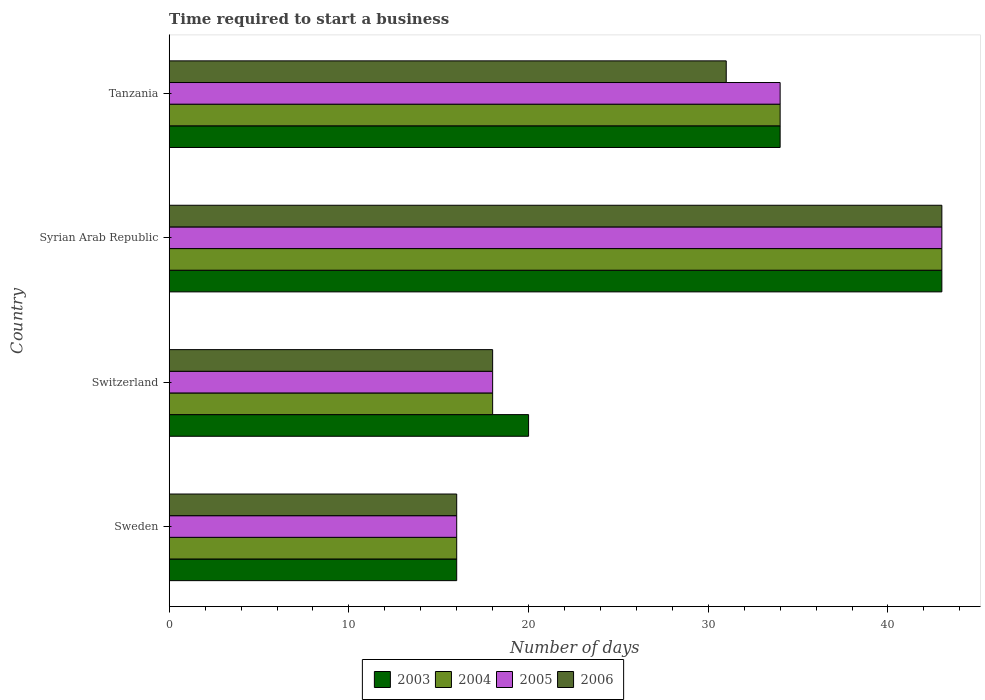Are the number of bars on each tick of the Y-axis equal?
Your response must be concise. Yes. What is the label of the 4th group of bars from the top?
Offer a very short reply. Sweden. In how many cases, is the number of bars for a given country not equal to the number of legend labels?
Give a very brief answer. 0. Across all countries, what is the minimum number of days required to start a business in 2005?
Give a very brief answer. 16. In which country was the number of days required to start a business in 2004 maximum?
Offer a very short reply. Syrian Arab Republic. In which country was the number of days required to start a business in 2004 minimum?
Your answer should be compact. Sweden. What is the total number of days required to start a business in 2006 in the graph?
Your answer should be compact. 108. What is the difference between the number of days required to start a business in 2003 in Syrian Arab Republic and that in Tanzania?
Your answer should be very brief. 9. What is the difference between the number of days required to start a business in 2005 in Syrian Arab Republic and the number of days required to start a business in 2003 in Sweden?
Your answer should be very brief. 27. What is the average number of days required to start a business in 2005 per country?
Offer a very short reply. 27.75. In how many countries, is the number of days required to start a business in 2006 greater than 22 days?
Make the answer very short. 2. What is the ratio of the number of days required to start a business in 2004 in Switzerland to that in Tanzania?
Ensure brevity in your answer.  0.53. Is the difference between the number of days required to start a business in 2006 in Sweden and Tanzania greater than the difference between the number of days required to start a business in 2005 in Sweden and Tanzania?
Keep it short and to the point. Yes. Is the sum of the number of days required to start a business in 2005 in Switzerland and Syrian Arab Republic greater than the maximum number of days required to start a business in 2004 across all countries?
Your answer should be very brief. Yes. What does the 3rd bar from the top in Syrian Arab Republic represents?
Provide a succinct answer. 2004. How many bars are there?
Offer a terse response. 16. How many countries are there in the graph?
Provide a succinct answer. 4. Does the graph contain any zero values?
Give a very brief answer. No. Does the graph contain grids?
Provide a short and direct response. No. How many legend labels are there?
Provide a succinct answer. 4. What is the title of the graph?
Your answer should be compact. Time required to start a business. Does "1974" appear as one of the legend labels in the graph?
Offer a terse response. No. What is the label or title of the X-axis?
Your response must be concise. Number of days. What is the Number of days in 2005 in Sweden?
Your answer should be very brief. 16. What is the Number of days of 2003 in Switzerland?
Keep it short and to the point. 20. What is the Number of days in 2006 in Switzerland?
Ensure brevity in your answer.  18. What is the Number of days in 2004 in Syrian Arab Republic?
Give a very brief answer. 43. What is the Number of days in 2006 in Syrian Arab Republic?
Give a very brief answer. 43. Across all countries, what is the maximum Number of days in 2004?
Your answer should be compact. 43. Across all countries, what is the maximum Number of days of 2005?
Offer a terse response. 43. Across all countries, what is the minimum Number of days of 2004?
Your response must be concise. 16. Across all countries, what is the minimum Number of days in 2005?
Ensure brevity in your answer.  16. What is the total Number of days of 2003 in the graph?
Offer a very short reply. 113. What is the total Number of days in 2004 in the graph?
Provide a succinct answer. 111. What is the total Number of days of 2005 in the graph?
Give a very brief answer. 111. What is the total Number of days in 2006 in the graph?
Offer a very short reply. 108. What is the difference between the Number of days of 2004 in Sweden and that in Switzerland?
Offer a very short reply. -2. What is the difference between the Number of days in 2005 in Sweden and that in Switzerland?
Provide a short and direct response. -2. What is the difference between the Number of days of 2006 in Sweden and that in Switzerland?
Your answer should be very brief. -2. What is the difference between the Number of days in 2005 in Sweden and that in Syrian Arab Republic?
Offer a very short reply. -27. What is the difference between the Number of days in 2006 in Sweden and that in Syrian Arab Republic?
Your response must be concise. -27. What is the difference between the Number of days of 2003 in Sweden and that in Tanzania?
Provide a short and direct response. -18. What is the difference between the Number of days in 2003 in Switzerland and that in Syrian Arab Republic?
Provide a short and direct response. -23. What is the difference between the Number of days of 2004 in Switzerland and that in Syrian Arab Republic?
Offer a terse response. -25. What is the difference between the Number of days in 2005 in Switzerland and that in Syrian Arab Republic?
Offer a very short reply. -25. What is the difference between the Number of days in 2006 in Switzerland and that in Syrian Arab Republic?
Your answer should be compact. -25. What is the difference between the Number of days of 2004 in Switzerland and that in Tanzania?
Provide a succinct answer. -16. What is the difference between the Number of days of 2005 in Switzerland and that in Tanzania?
Give a very brief answer. -16. What is the difference between the Number of days in 2003 in Syrian Arab Republic and that in Tanzania?
Make the answer very short. 9. What is the difference between the Number of days of 2004 in Syrian Arab Republic and that in Tanzania?
Provide a succinct answer. 9. What is the difference between the Number of days of 2006 in Syrian Arab Republic and that in Tanzania?
Your response must be concise. 12. What is the difference between the Number of days in 2003 in Sweden and the Number of days in 2006 in Switzerland?
Offer a terse response. -2. What is the difference between the Number of days in 2004 in Sweden and the Number of days in 2005 in Switzerland?
Offer a terse response. -2. What is the difference between the Number of days of 2004 in Sweden and the Number of days of 2006 in Switzerland?
Make the answer very short. -2. What is the difference between the Number of days of 2003 in Sweden and the Number of days of 2004 in Syrian Arab Republic?
Provide a succinct answer. -27. What is the difference between the Number of days of 2004 in Sweden and the Number of days of 2006 in Syrian Arab Republic?
Keep it short and to the point. -27. What is the difference between the Number of days in 2003 in Sweden and the Number of days in 2005 in Tanzania?
Keep it short and to the point. -18. What is the difference between the Number of days in 2005 in Sweden and the Number of days in 2006 in Tanzania?
Offer a very short reply. -15. What is the difference between the Number of days of 2003 in Switzerland and the Number of days of 2004 in Syrian Arab Republic?
Your response must be concise. -23. What is the difference between the Number of days of 2004 in Switzerland and the Number of days of 2005 in Syrian Arab Republic?
Provide a succinct answer. -25. What is the difference between the Number of days of 2005 in Switzerland and the Number of days of 2006 in Syrian Arab Republic?
Your answer should be very brief. -25. What is the difference between the Number of days of 2003 in Switzerland and the Number of days of 2005 in Tanzania?
Offer a very short reply. -14. What is the difference between the Number of days in 2003 in Switzerland and the Number of days in 2006 in Tanzania?
Make the answer very short. -11. What is the difference between the Number of days of 2004 in Switzerland and the Number of days of 2006 in Tanzania?
Ensure brevity in your answer.  -13. What is the difference between the Number of days in 2003 in Syrian Arab Republic and the Number of days in 2004 in Tanzania?
Offer a very short reply. 9. What is the difference between the Number of days in 2003 in Syrian Arab Republic and the Number of days in 2005 in Tanzania?
Your response must be concise. 9. What is the difference between the Number of days in 2003 in Syrian Arab Republic and the Number of days in 2006 in Tanzania?
Make the answer very short. 12. What is the difference between the Number of days of 2004 in Syrian Arab Republic and the Number of days of 2006 in Tanzania?
Ensure brevity in your answer.  12. What is the difference between the Number of days of 2005 in Syrian Arab Republic and the Number of days of 2006 in Tanzania?
Make the answer very short. 12. What is the average Number of days of 2003 per country?
Provide a succinct answer. 28.25. What is the average Number of days of 2004 per country?
Provide a succinct answer. 27.75. What is the average Number of days of 2005 per country?
Offer a very short reply. 27.75. What is the difference between the Number of days of 2003 and Number of days of 2004 in Sweden?
Give a very brief answer. 0. What is the difference between the Number of days in 2003 and Number of days in 2005 in Sweden?
Make the answer very short. 0. What is the difference between the Number of days in 2004 and Number of days in 2005 in Sweden?
Your answer should be compact. 0. What is the difference between the Number of days of 2003 and Number of days of 2004 in Switzerland?
Offer a very short reply. 2. What is the difference between the Number of days of 2004 and Number of days of 2005 in Switzerland?
Offer a terse response. 0. What is the difference between the Number of days in 2005 and Number of days in 2006 in Switzerland?
Your answer should be very brief. 0. What is the difference between the Number of days in 2003 and Number of days in 2005 in Syrian Arab Republic?
Your response must be concise. 0. What is the difference between the Number of days of 2005 and Number of days of 2006 in Syrian Arab Republic?
Offer a terse response. 0. What is the difference between the Number of days of 2003 and Number of days of 2004 in Tanzania?
Your response must be concise. 0. What is the difference between the Number of days in 2003 and Number of days in 2006 in Tanzania?
Give a very brief answer. 3. What is the difference between the Number of days of 2004 and Number of days of 2006 in Tanzania?
Give a very brief answer. 3. What is the ratio of the Number of days of 2003 in Sweden to that in Switzerland?
Give a very brief answer. 0.8. What is the ratio of the Number of days of 2004 in Sweden to that in Switzerland?
Your response must be concise. 0.89. What is the ratio of the Number of days of 2003 in Sweden to that in Syrian Arab Republic?
Your answer should be very brief. 0.37. What is the ratio of the Number of days of 2004 in Sweden to that in Syrian Arab Republic?
Your answer should be compact. 0.37. What is the ratio of the Number of days in 2005 in Sweden to that in Syrian Arab Republic?
Make the answer very short. 0.37. What is the ratio of the Number of days of 2006 in Sweden to that in Syrian Arab Republic?
Your response must be concise. 0.37. What is the ratio of the Number of days of 2003 in Sweden to that in Tanzania?
Your answer should be very brief. 0.47. What is the ratio of the Number of days of 2004 in Sweden to that in Tanzania?
Your response must be concise. 0.47. What is the ratio of the Number of days of 2005 in Sweden to that in Tanzania?
Ensure brevity in your answer.  0.47. What is the ratio of the Number of days of 2006 in Sweden to that in Tanzania?
Your answer should be compact. 0.52. What is the ratio of the Number of days of 2003 in Switzerland to that in Syrian Arab Republic?
Offer a terse response. 0.47. What is the ratio of the Number of days of 2004 in Switzerland to that in Syrian Arab Republic?
Provide a short and direct response. 0.42. What is the ratio of the Number of days of 2005 in Switzerland to that in Syrian Arab Republic?
Your answer should be very brief. 0.42. What is the ratio of the Number of days of 2006 in Switzerland to that in Syrian Arab Republic?
Keep it short and to the point. 0.42. What is the ratio of the Number of days in 2003 in Switzerland to that in Tanzania?
Your answer should be very brief. 0.59. What is the ratio of the Number of days of 2004 in Switzerland to that in Tanzania?
Keep it short and to the point. 0.53. What is the ratio of the Number of days of 2005 in Switzerland to that in Tanzania?
Offer a terse response. 0.53. What is the ratio of the Number of days of 2006 in Switzerland to that in Tanzania?
Provide a short and direct response. 0.58. What is the ratio of the Number of days in 2003 in Syrian Arab Republic to that in Tanzania?
Your answer should be compact. 1.26. What is the ratio of the Number of days of 2004 in Syrian Arab Republic to that in Tanzania?
Ensure brevity in your answer.  1.26. What is the ratio of the Number of days in 2005 in Syrian Arab Republic to that in Tanzania?
Provide a succinct answer. 1.26. What is the ratio of the Number of days in 2006 in Syrian Arab Republic to that in Tanzania?
Ensure brevity in your answer.  1.39. What is the difference between the highest and the second highest Number of days of 2003?
Offer a very short reply. 9. What is the difference between the highest and the second highest Number of days in 2004?
Your response must be concise. 9. What is the difference between the highest and the second highest Number of days of 2006?
Ensure brevity in your answer.  12. What is the difference between the highest and the lowest Number of days of 2003?
Give a very brief answer. 27. What is the difference between the highest and the lowest Number of days in 2004?
Provide a succinct answer. 27. 